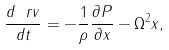Convert formula to latex. <formula><loc_0><loc_0><loc_500><loc_500>\frac { d \ r v } { d t } = - \frac { 1 } { \rho } \frac { \partial P } { \partial x } - \Omega ^ { 2 } x ,</formula> 